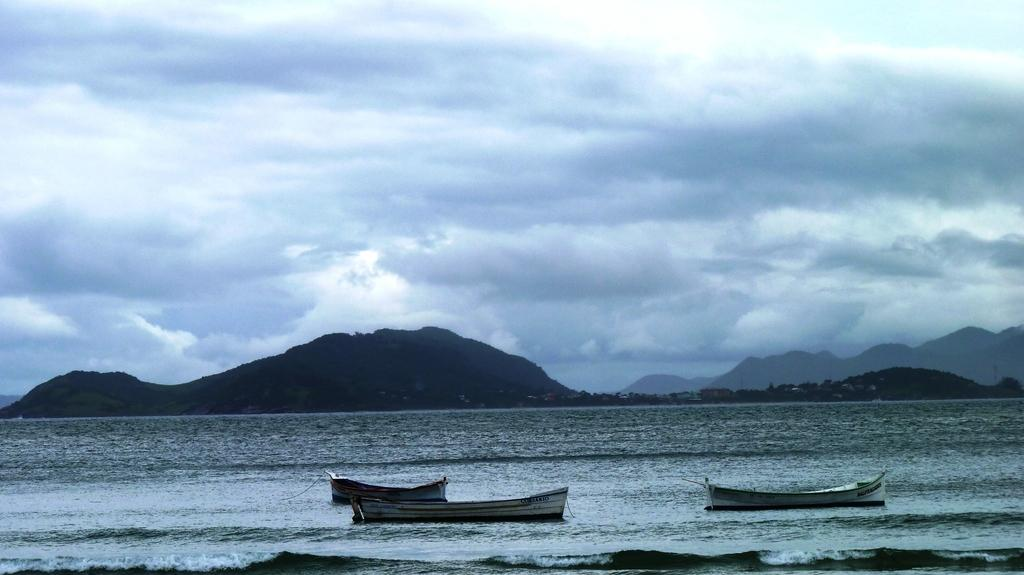Where was the image taken? The image was taken at a beach. What can be seen on the water in the image? There are three boats on the surface of the water. What is visible in the background of the image? Mountains and hills can be seen in the background of the image. How would you describe the sky in the image? The sky is cloudy in the image. What type of van can be seen parked near the boats in the image? There is no van present in the image; it features a beach with boats and a cloudy sky. 